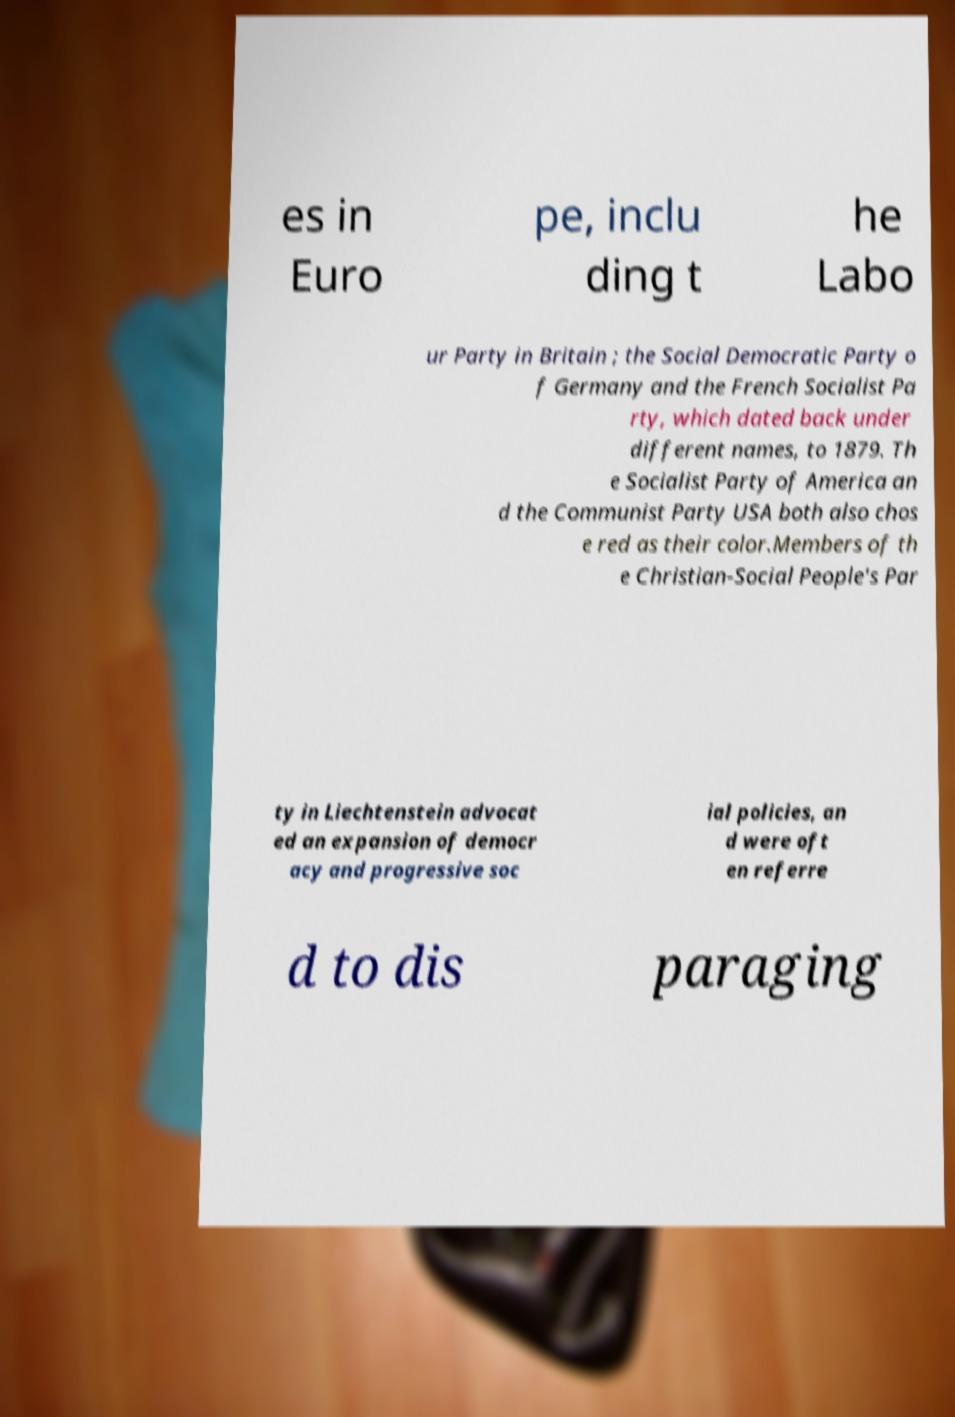Could you extract and type out the text from this image? es in Euro pe, inclu ding t he Labo ur Party in Britain ; the Social Democratic Party o f Germany and the French Socialist Pa rty, which dated back under different names, to 1879. Th e Socialist Party of America an d the Communist Party USA both also chos e red as their color.Members of th e Christian-Social People's Par ty in Liechtenstein advocat ed an expansion of democr acy and progressive soc ial policies, an d were oft en referre d to dis paraging 